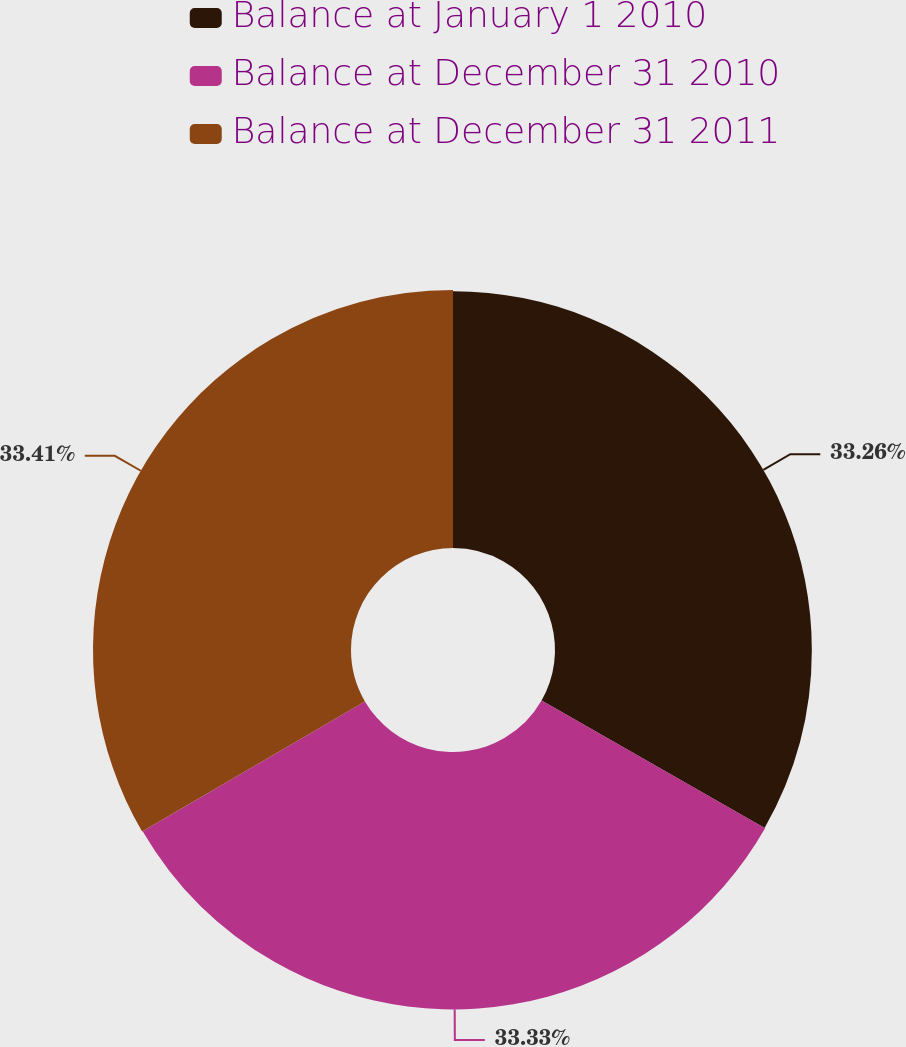Convert chart. <chart><loc_0><loc_0><loc_500><loc_500><pie_chart><fcel>Balance at January 1 2010<fcel>Balance at December 31 2010<fcel>Balance at December 31 2011<nl><fcel>33.26%<fcel>33.33%<fcel>33.41%<nl></chart> 